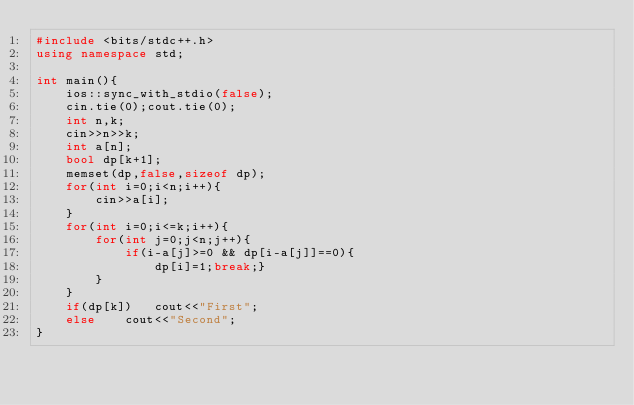<code> <loc_0><loc_0><loc_500><loc_500><_C++_>#include <bits/stdc++.h>
using namespace std;

int main(){
    ios::sync_with_stdio(false);
    cin.tie(0);cout.tie(0);
    int n,k;
    cin>>n>>k;
    int a[n];
    bool dp[k+1];
    memset(dp,false,sizeof dp);
    for(int i=0;i<n;i++){
        cin>>a[i];
    }
    for(int i=0;i<=k;i++){
        for(int j=0;j<n;j++){
            if(i-a[j]>=0 && dp[i-a[j]]==0){
                dp[i]=1;break;}
        }
    }
    if(dp[k])   cout<<"First";
    else    cout<<"Second";
}</code> 